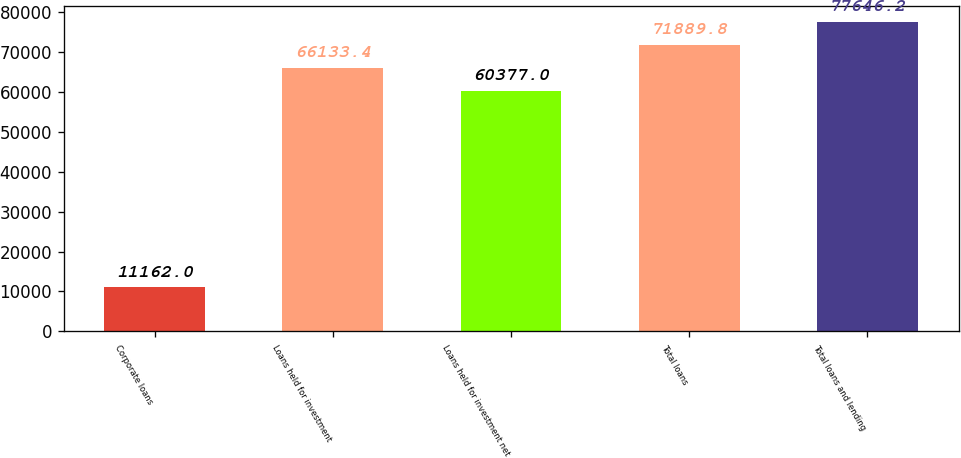<chart> <loc_0><loc_0><loc_500><loc_500><bar_chart><fcel>Corporate loans<fcel>Loans held for investment<fcel>Loans held for investment net<fcel>Total loans<fcel>Total loans and lending<nl><fcel>11162<fcel>66133.4<fcel>60377<fcel>71889.8<fcel>77646.2<nl></chart> 